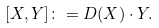Convert formula to latex. <formula><loc_0><loc_0><loc_500><loc_500>[ X , Y ] \colon = D ( X ) \cdot Y .</formula> 